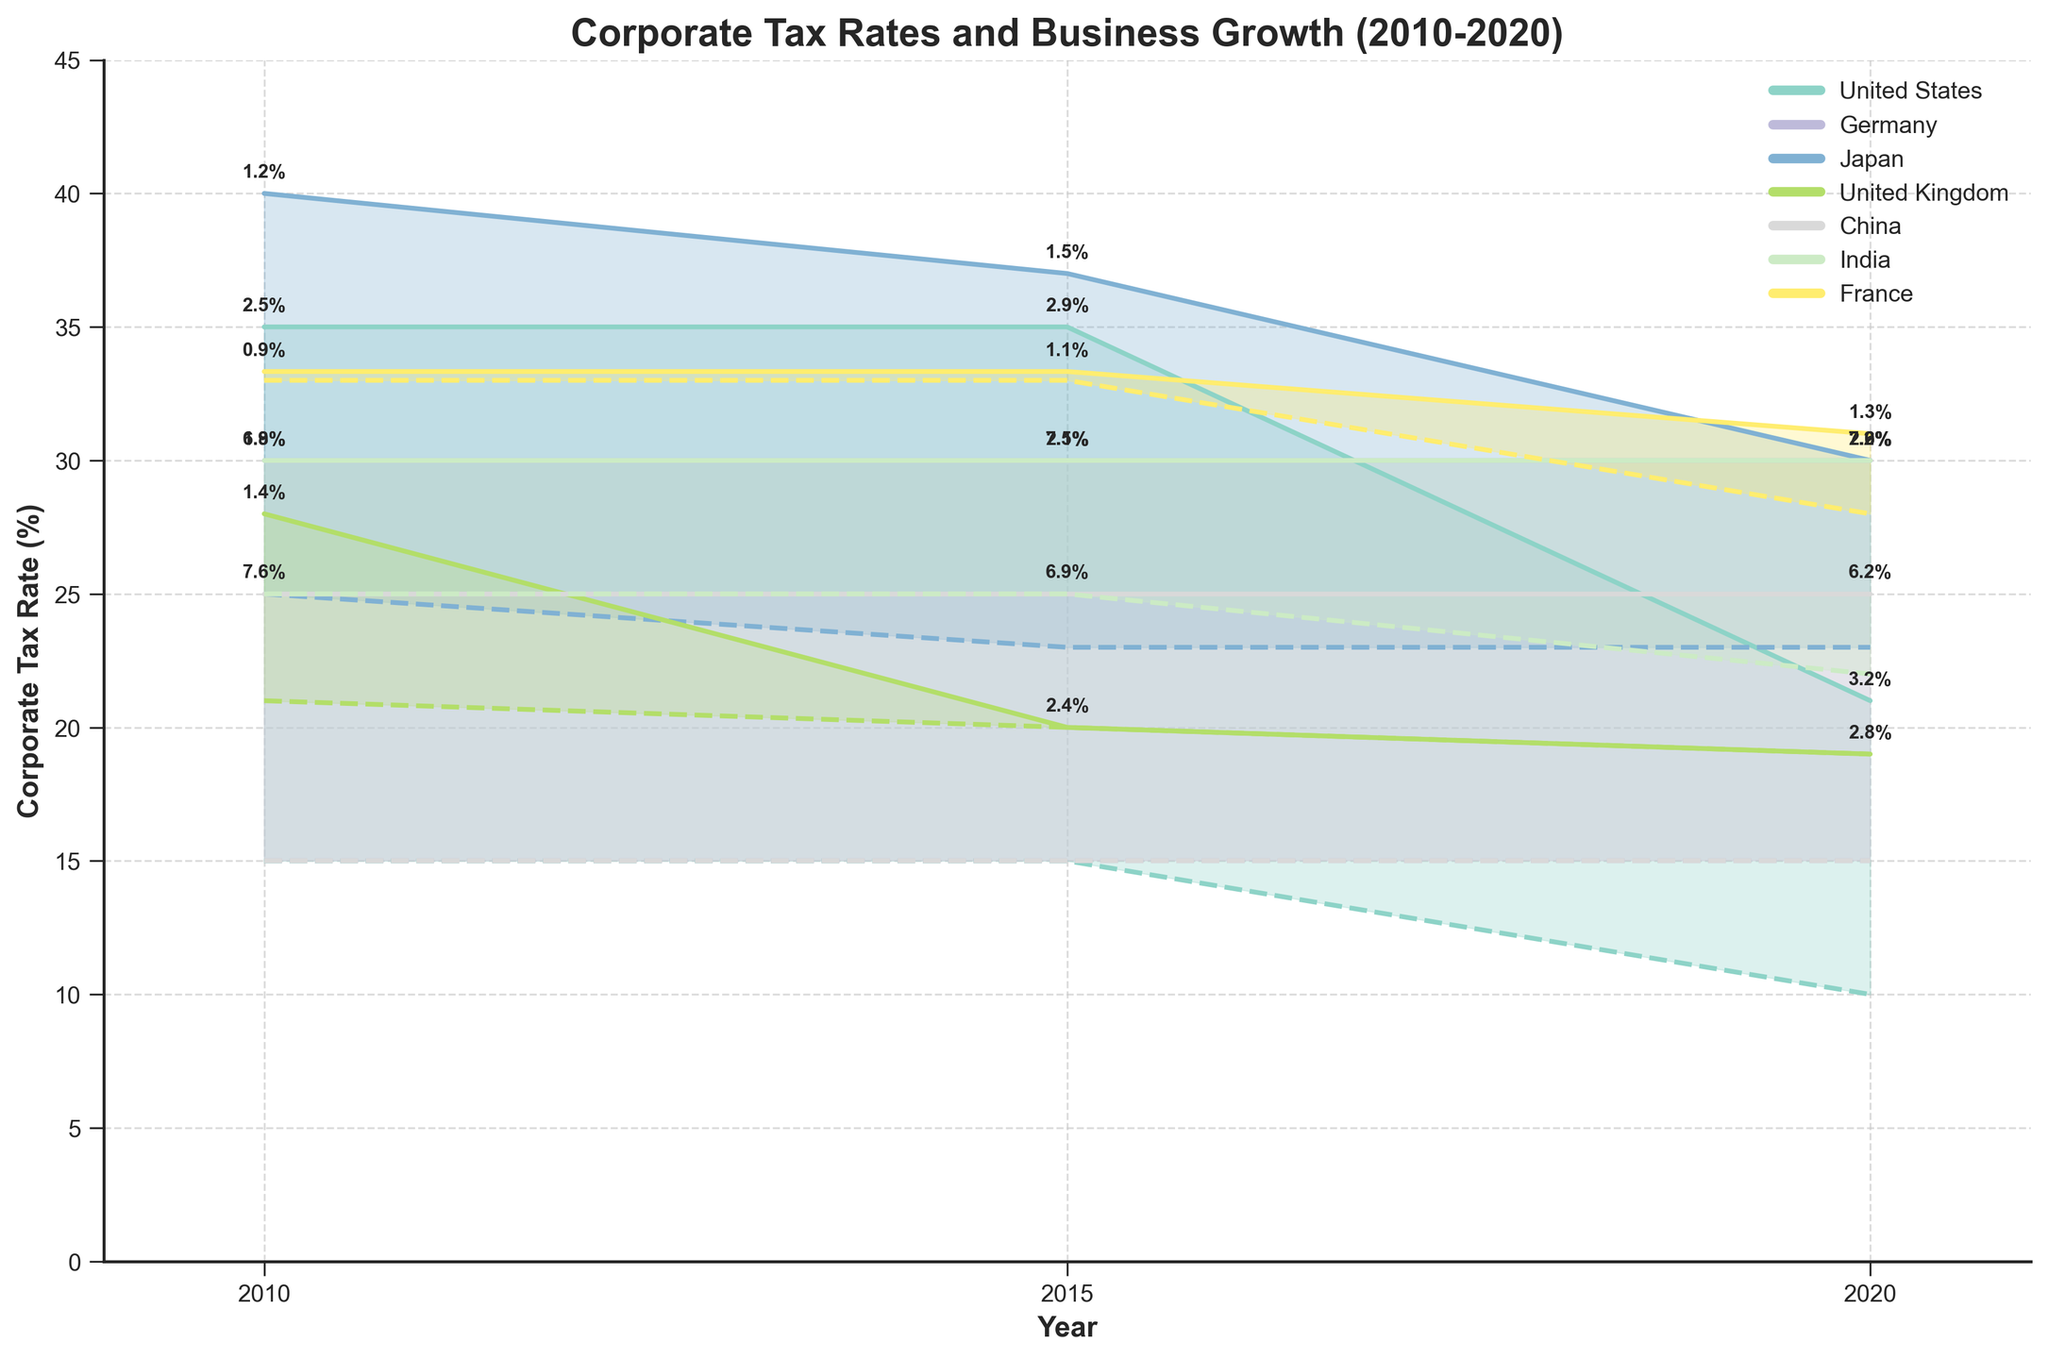What is the range of corporate tax rates in the United States in 2010? By checking the fill area for the United States in 2010 on the y-axis, the minimum rate is 15% and the maximum rate is 35%.
Answer: 15% - 35% How does the business growth rate in India in 2015 compare to Germany in the same year? To answer this, compare the annotated growth rates in 2015 for India and Germany. India's growth rate is 7.5% and Germany's is 2.1%, so India’s growth rate is higher.
Answer: India's growth rate is higher Which country showed the highest business growth rate in 2020? Look at the annotations on the plot for 2020, the highest business growth rate annotated is for India with 7.2%.
Answer: India What is the title of the chart? The title of the chart is displayed at the top center and reads 'Corporate Tax Rates and Business Growth (2010-2020)'.
Answer: Corporate Tax Rates and Business Growth (2010-2020) Which country experienced a decrease in the maximum corporate tax rate from 2010 to 2020? Japan is the only country where the maximum rate decreased from 40% in 2010 to 30% in 2020, visible from the y-axis reduction over the years.
Answer: Japan What was the range of corporate tax rates in France in 2015? Considering the y-values of the fill area corresponding to France in 2015, the minimum and maximum tax rates are approximately 33% and 33.33%, respectively.
Answer: 33% - 33.33% How did the growth rate in Japan change from 2015 to 2020? By inspecting the annotations from 2015 to 2020 for Japan, the growth rate increased from 1.5% to 2.0%.
Answer: Increased Which countries maintained the same minimum corporate tax rate throughout the period 2010 to 2020? Check the minimum tax rate lines for consistency over the years for each country. Germany and China both maintained their minimum rates at 15% consistently.
Answer: Germany and China By how much did the business growth rate in the United States increase from 2010 to 2020? The United States’ growth rate in 2010 was 2.5% and 3.2% in 2020. The increase can be calculated as 3.2% - 2.5% = 0.7%.
Answer: 0.7% What are the y-axis tick marks displaying? The y-axis tick marks show increments of corporate tax rates, ranging from 0% to 45% in steps of 5%.
Answer: Corporate tax rates in increments of 5% 